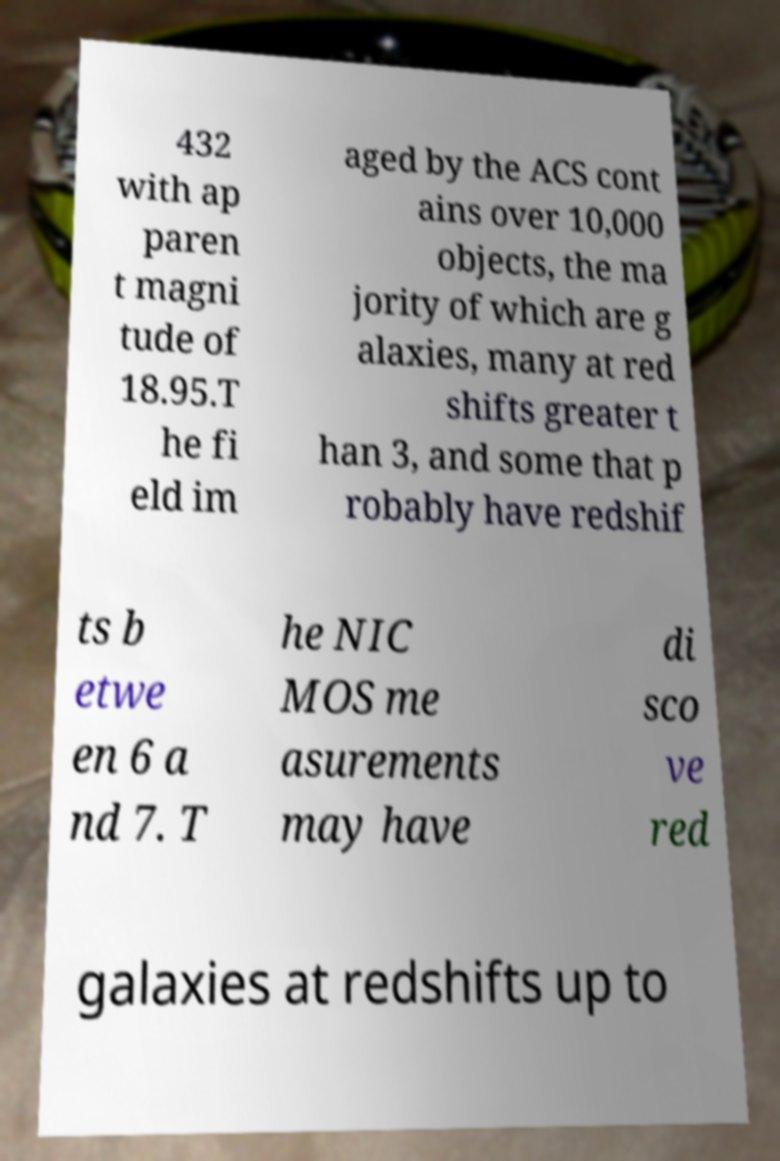Can you read and provide the text displayed in the image?This photo seems to have some interesting text. Can you extract and type it out for me? 432 with ap paren t magni tude of 18.95.T he fi eld im aged by the ACS cont ains over 10,000 objects, the ma jority of which are g alaxies, many at red shifts greater t han 3, and some that p robably have redshif ts b etwe en 6 a nd 7. T he NIC MOS me asurements may have di sco ve red galaxies at redshifts up to 